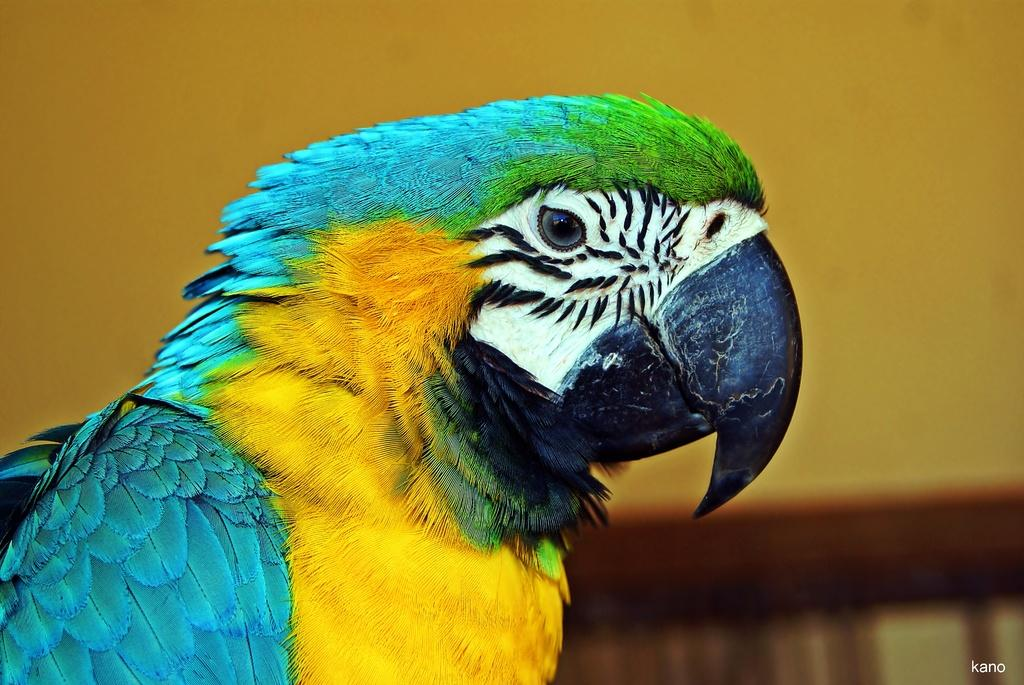What type of animal can be seen in the picture? There is a bird in the picture. Can you describe the appearance of the bird? The bird is colorful. What color is the background of the bird? The background of the bird is blue. What type of drug is the bird holding in the picture? There is no drug present in the image; it is a bird in a blue background. 